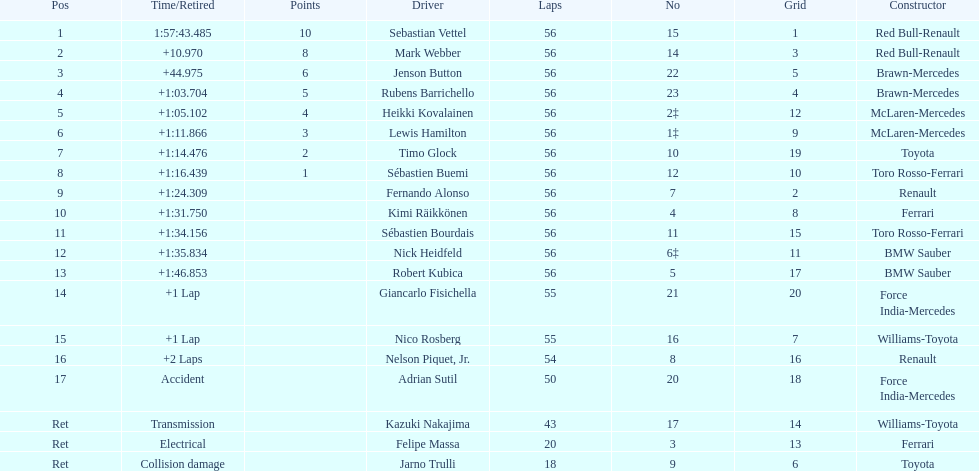What is the name of a driver that ferrari was not a constructor for? Sebastian Vettel. 